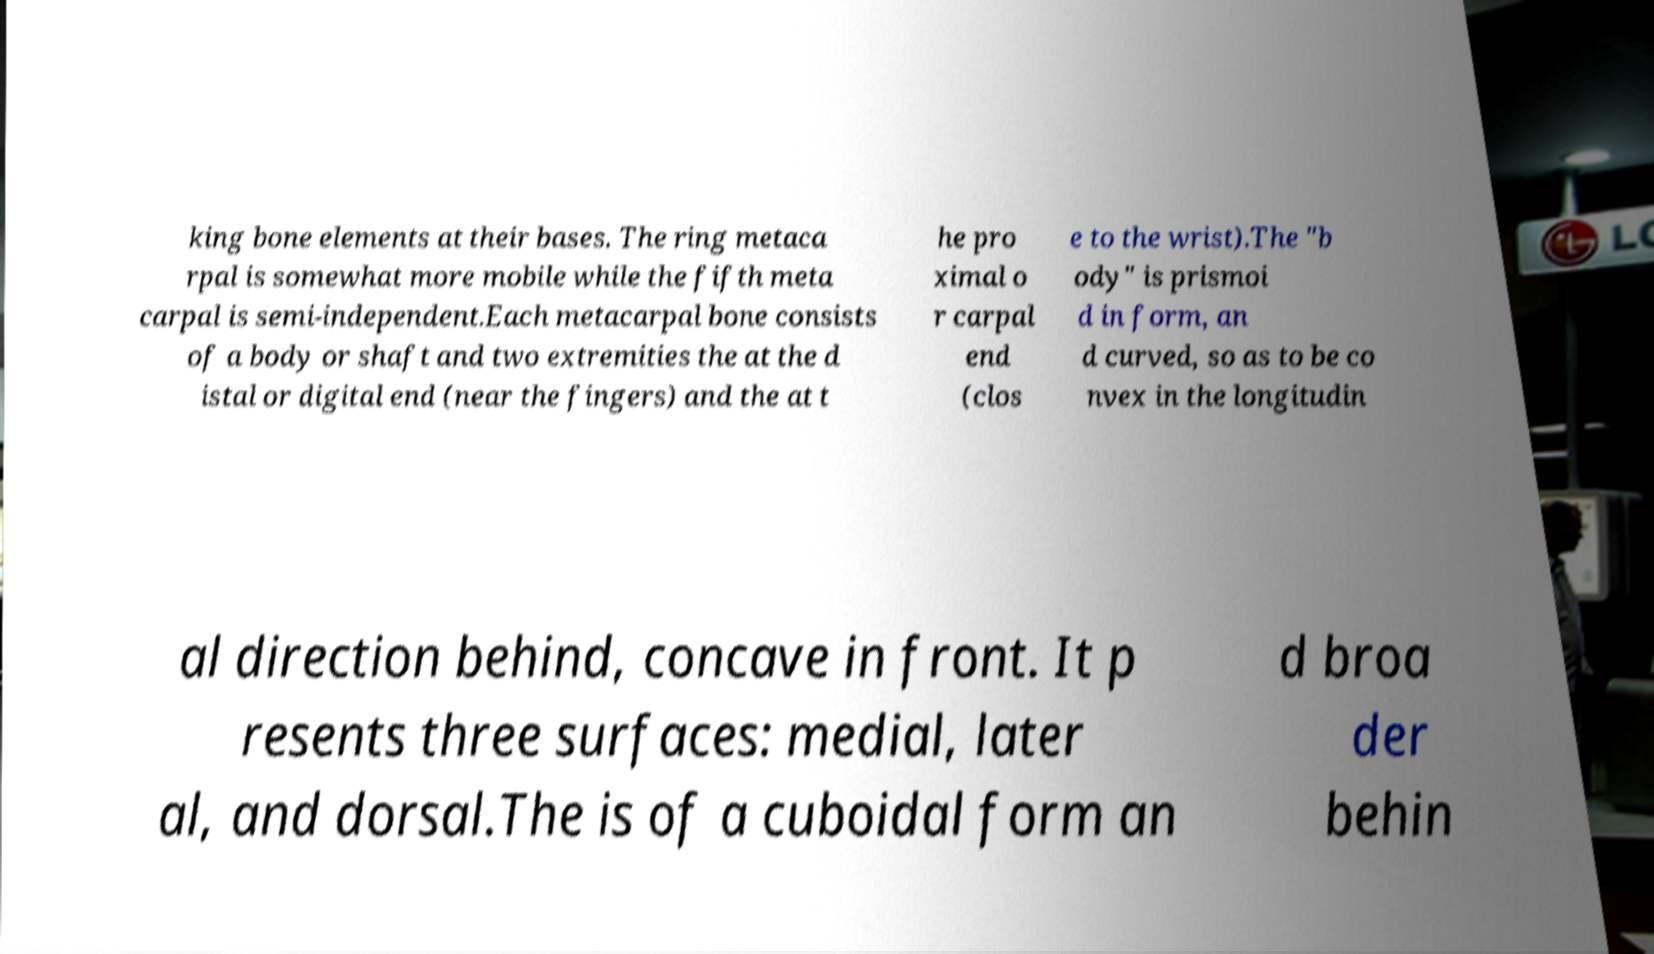Could you assist in decoding the text presented in this image and type it out clearly? king bone elements at their bases. The ring metaca rpal is somewhat more mobile while the fifth meta carpal is semi-independent.Each metacarpal bone consists of a body or shaft and two extremities the at the d istal or digital end (near the fingers) and the at t he pro ximal o r carpal end (clos e to the wrist).The "b ody" is prismoi d in form, an d curved, so as to be co nvex in the longitudin al direction behind, concave in front. It p resents three surfaces: medial, later al, and dorsal.The is of a cuboidal form an d broa der behin 